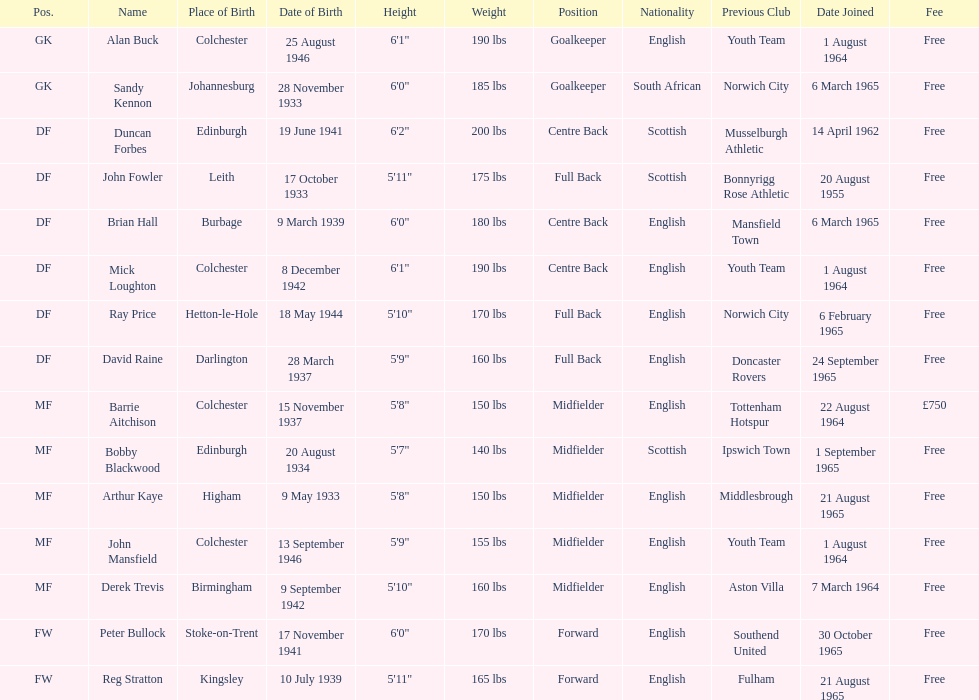Which player is the oldest? Arthur Kaye. Would you mind parsing the complete table? {'header': ['Pos.', 'Name', 'Place of Birth', 'Date of Birth', 'Height', 'Weight', 'Position', 'Nationality', 'Previous Club', 'Date Joined', 'Fee'], 'rows': [['GK', 'Alan Buck', 'Colchester', '25 August 1946', '6\'1"', '190 lbs', 'Goalkeeper', 'English', 'Youth Team', '1 August 1964', 'Free'], ['GK', 'Sandy Kennon', 'Johannesburg', '28 November 1933', '6\'0"', '185 lbs', 'Goalkeeper', 'South African', 'Norwich City', '6 March 1965', 'Free'], ['DF', 'Duncan Forbes', 'Edinburgh', '19 June 1941', '6\'2"', '200 lbs', 'Centre Back', 'Scottish', 'Musselburgh Athletic', '14 April 1962', 'Free'], ['DF', 'John Fowler', 'Leith', '17 October 1933', '5\'11"', '175 lbs', 'Full Back', 'Scottish', 'Bonnyrigg Rose Athletic', '20 August 1955', 'Free'], ['DF', 'Brian Hall', 'Burbage', '9 March 1939', '6\'0"', '180 lbs', 'Centre Back', 'English', 'Mansfield Town', '6 March 1965', 'Free'], ['DF', 'Mick Loughton', 'Colchester', '8 December 1942', '6\'1"', '190 lbs', 'Centre Back', 'English', 'Youth Team', '1 August 1964', 'Free'], ['DF', 'Ray Price', 'Hetton-le-Hole', '18 May 1944', '5\'10"', '170 lbs', 'Full Back', 'English', 'Norwich City', '6 February 1965', 'Free'], ['DF', 'David Raine', 'Darlington', '28 March 1937', '5\'9"', '160 lbs', 'Full Back', 'English', 'Doncaster Rovers', '24 September 1965', 'Free'], ['MF', 'Barrie Aitchison', 'Colchester', '15 November 1937', '5\'8"', '150 lbs', 'Midfielder', 'English', 'Tottenham Hotspur', '22 August 1964', '£750'], ['MF', 'Bobby Blackwood', 'Edinburgh', '20 August 1934', '5\'7"', '140 lbs', 'Midfielder', 'Scottish', 'Ipswich Town', '1 September 1965', 'Free'], ['MF', 'Arthur Kaye', 'Higham', '9 May 1933', '5\'8"', '150 lbs', 'Midfielder', 'English', 'Middlesbrough', '21 August 1965', 'Free'], ['MF', 'John Mansfield', 'Colchester', '13 September 1946', '5\'9"', '155 lbs', 'Midfielder', 'English', 'Youth Team', '1 August 1964', 'Free'], ['MF', 'Derek Trevis', 'Birmingham', '9 September 1942', '5\'10"', '160 lbs', 'Midfielder', 'English', 'Aston Villa', '7 March 1964', 'Free'], ['FW', 'Peter Bullock', 'Stoke-on-Trent', '17 November 1941', '6\'0"', '170 lbs', 'Forward', 'English', 'Southend United', '30 October 1965', 'Free'], ['FW', 'Reg Stratton', 'Kingsley', '10 July 1939', '5\'11"', '165 lbs', 'Forward', 'English', 'Fulham', '21 August 1965', 'Free']]} 